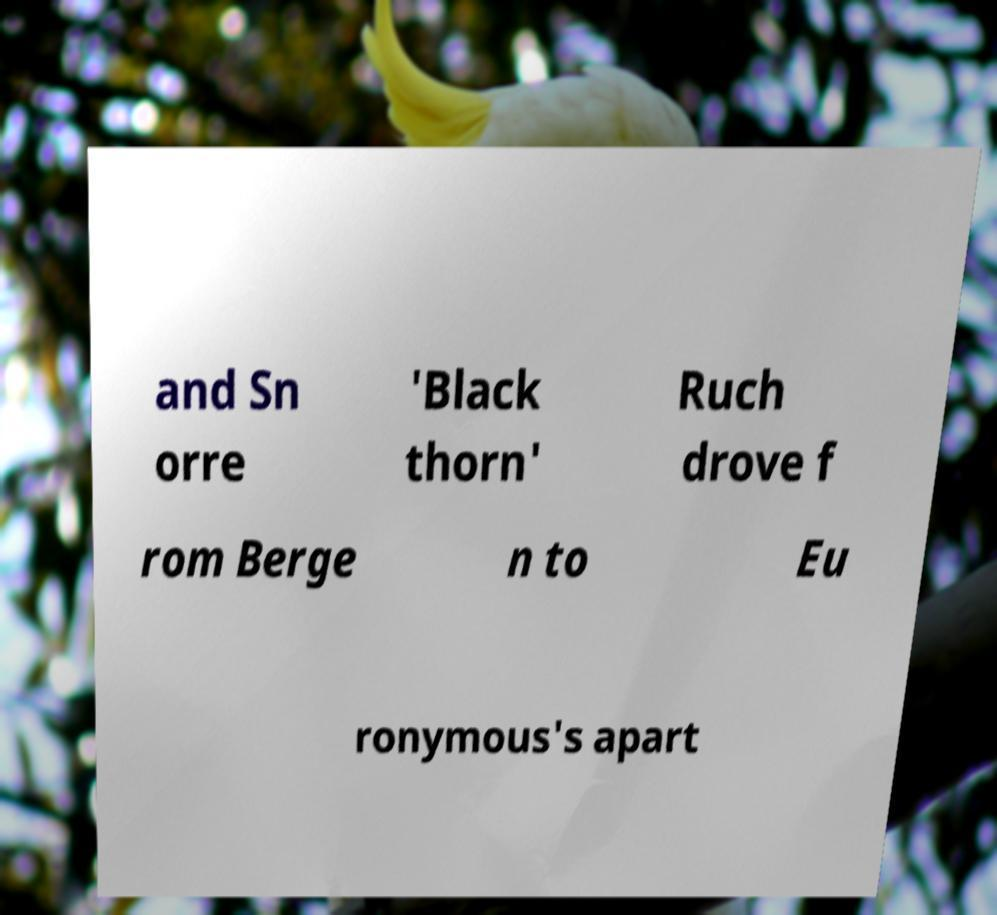What messages or text are displayed in this image? I need them in a readable, typed format. and Sn orre 'Black thorn' Ruch drove f rom Berge n to Eu ronymous's apart 